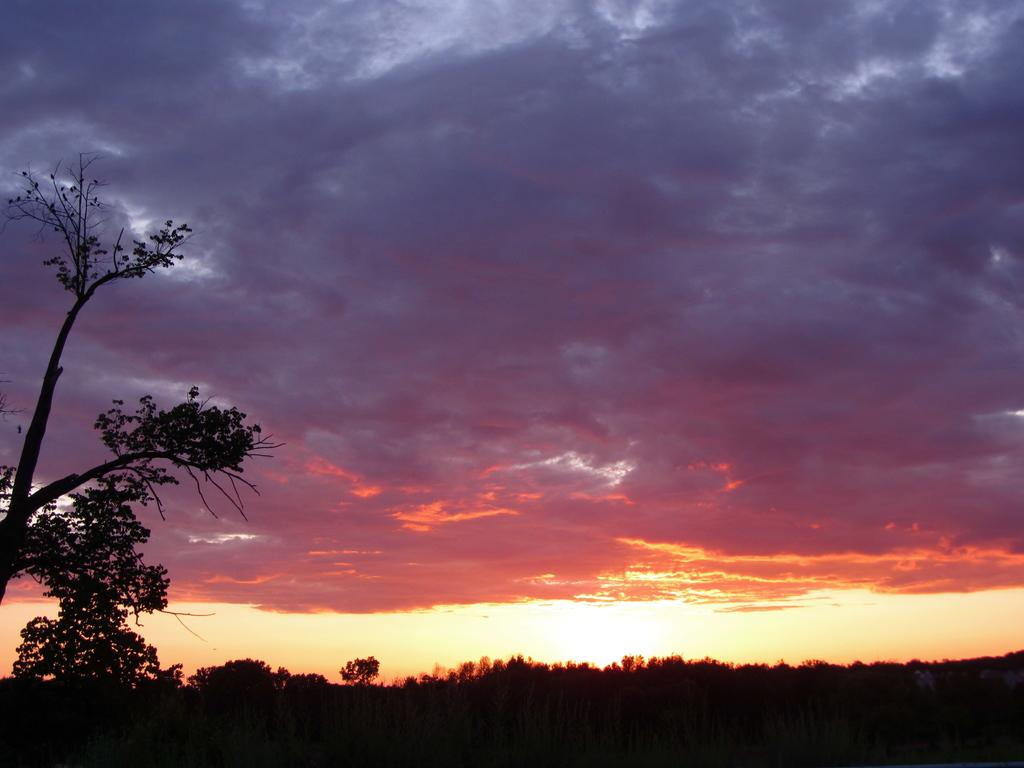Where was the picture taken? The picture was clicked outside. What can be seen in the foreground of the image? There are trees in the foreground of the image. What is visible in the background of the image? The sky is visible in the background of the image. How would you describe the sky in the image? The sky is full of clouds. What else can be seen in the background of the image besides the sky? There are other items visible in the background of the image. What is the topic of the discussion taking place in the image? There is no discussion taking place in the image; it is a still photograph. 